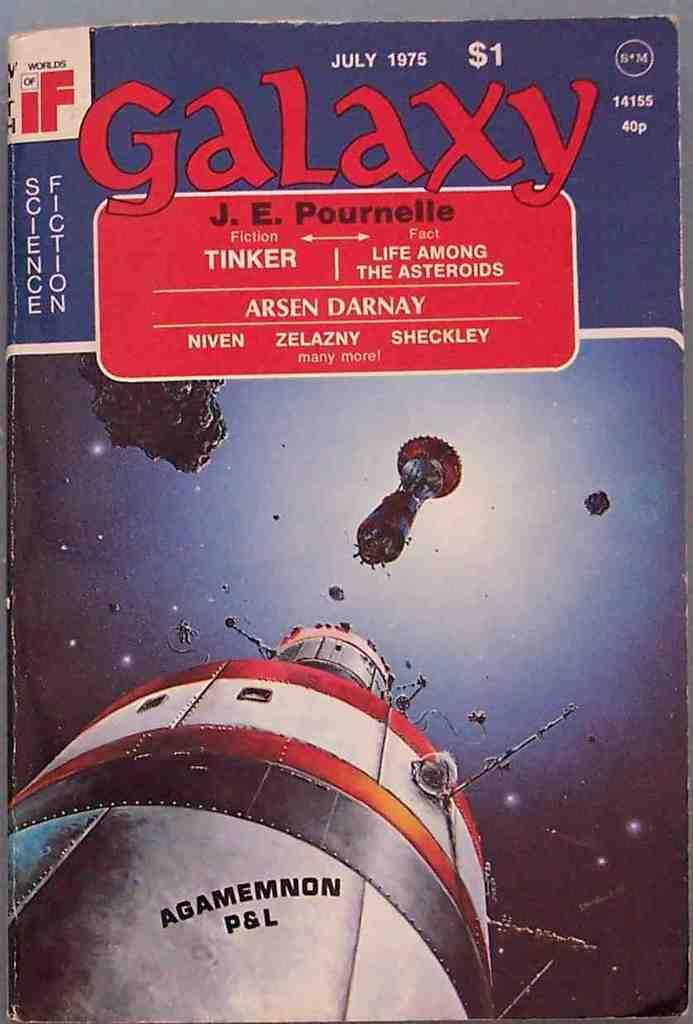How much money did this magazine originally cost?
Offer a terse response. $1. When was this published?
Ensure brevity in your answer.  July 1975. 